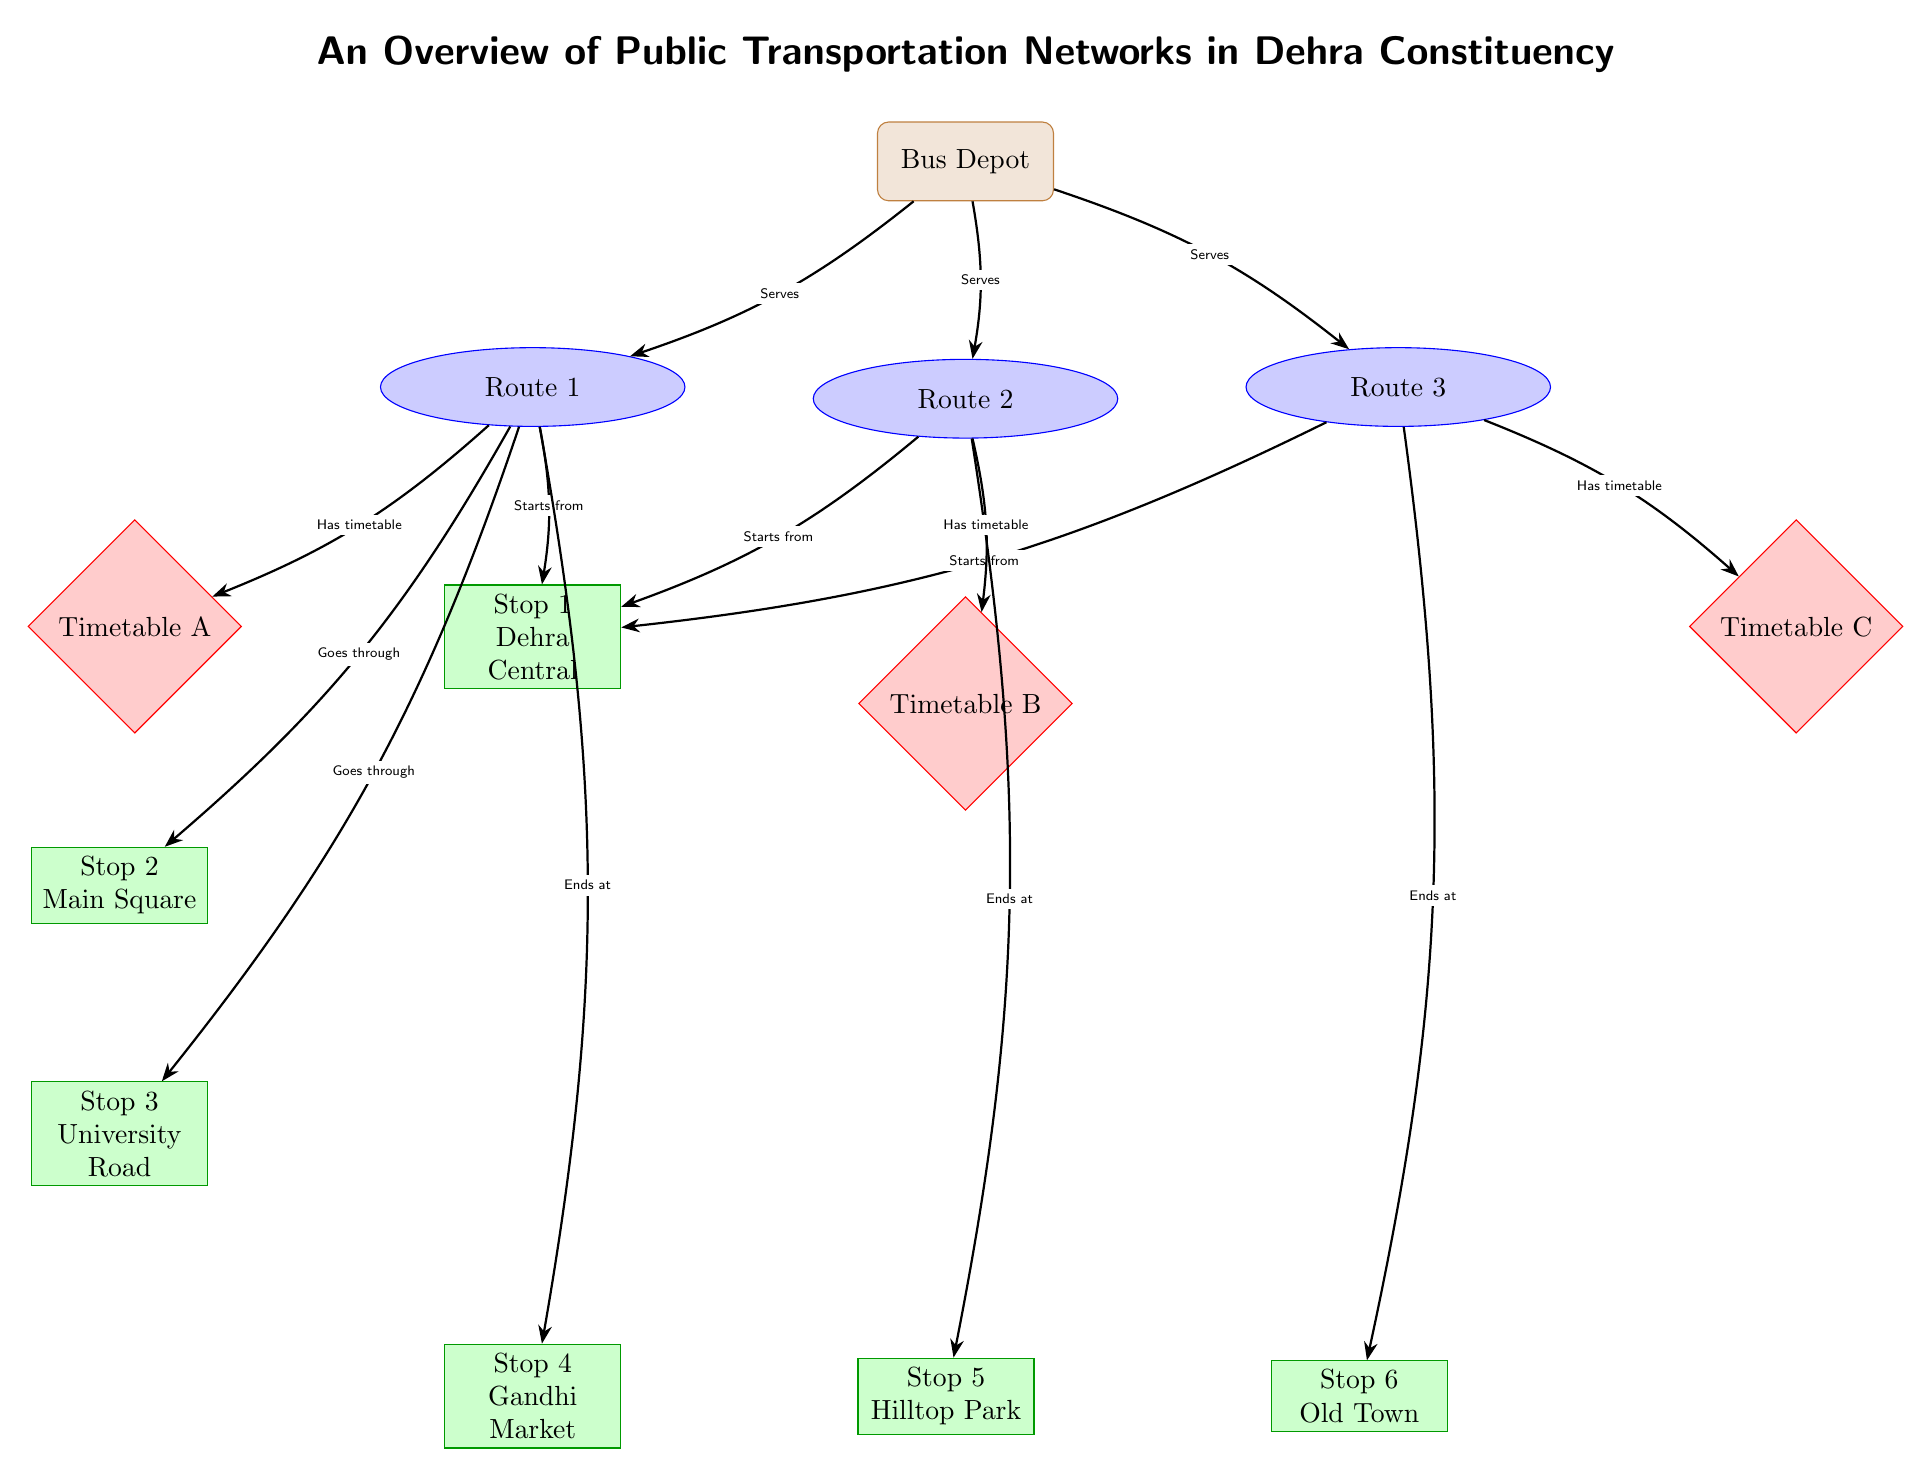What is the name of the depot? The name of the depot is found in the top node labeled as "Bus Depot."
Answer: Bus Depot How many bus routes are shown? There are three routes indicated in the diagram, represented by the nodes labeled Route 1, Route 2, and Route 3.
Answer: 3 Which stop does Route 1 end at? To determine the ending stop for Route 1, we can follow the arrow that points from Route 1 and ends at the stop labeled "Stop 4\\Gandhi Market."
Answer: Stop 4\\Gandhi Market What is the relationship between Route 2 and Stop 5? The diagram shows that there is an arrow from Route 2 that ends at Stop 5, indicating that Route 2 ends there.
Answer: Ends at Which stop serves as the starting point for all routes? The starting point for all routes is indicated by the arrows pointing from each route to the stop labeled "Stop 1\\Dehra Central."
Answer: Stop 1\\Dehra Central What timetables are associated with the routes? Each route has its corresponding timetable; Route 1 has Timetable A, Route 2 has Timetable B, and Route 3 has Timetable C, as shown by the arrows leading to the timetable nodes.
Answer: Timetable A, Timetable B, Timetable C How does Route 1 connect to Stop 3? The connection is indicated by an arrow from Route 1 which points towards Stop 3, signifying that Route 1 goes through this stop.
Answer: Goes through Which color represents the bus routes? The bus routes are marked in blue according to the color coding represented in the diagram.
Answer: Blue What is the shape of the nodes representing bus stops? The nodes that represent bus stops are rectangular in shape, as noted in the styles declared in the code for stops.
Answer: Rectangle 